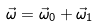<formula> <loc_0><loc_0><loc_500><loc_500>\vec { \omega } = \vec { \omega } _ { 0 } + \vec { \omega } _ { 1 }</formula> 